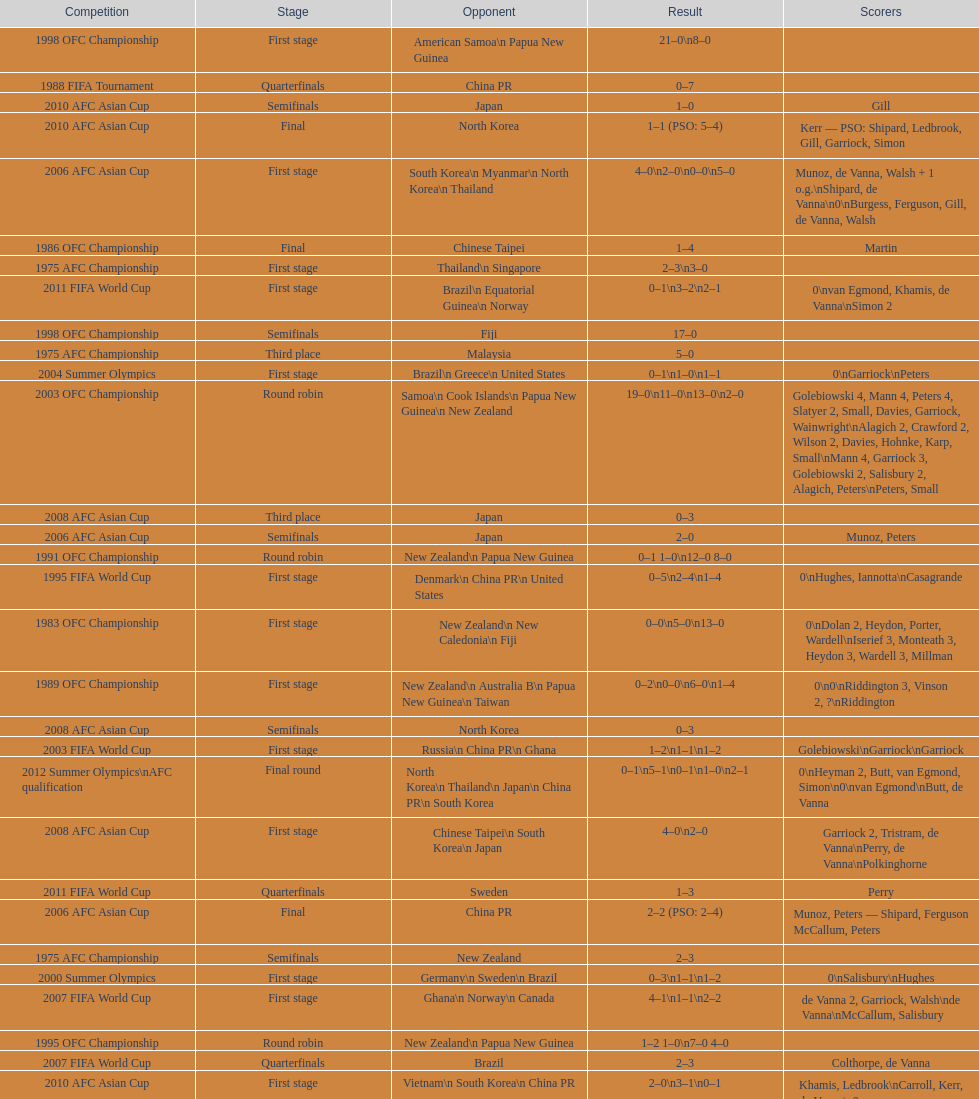How many players scored during the 1983 ofc championship competition? 9. Could you parse the entire table? {'header': ['Competition', 'Stage', 'Opponent', 'Result', 'Scorers'], 'rows': [['1998 OFC Championship', 'First stage', 'American Samoa\\n\xa0Papua New Guinea', '21–0\\n8–0', ''], ['1988 FIFA Tournament', 'Quarterfinals', 'China PR', '0–7', ''], ['2010 AFC Asian Cup', 'Semifinals', 'Japan', '1–0', 'Gill'], ['2010 AFC Asian Cup', 'Final', 'North Korea', '1–1 (PSO: 5–4)', 'Kerr — PSO: Shipard, Ledbrook, Gill, Garriock, Simon'], ['2006 AFC Asian Cup', 'First stage', 'South Korea\\n\xa0Myanmar\\n\xa0North Korea\\n\xa0Thailand', '4–0\\n2–0\\n0–0\\n5–0', 'Munoz, de Vanna, Walsh + 1 o.g.\\nShipard, de Vanna\\n0\\nBurgess, Ferguson, Gill, de Vanna, Walsh'], ['1986 OFC Championship', 'Final', 'Chinese Taipei', '1–4', 'Martin'], ['1975 AFC Championship', 'First stage', 'Thailand\\n\xa0Singapore', '2–3\\n3–0', ''], ['2011 FIFA World Cup', 'First stage', 'Brazil\\n\xa0Equatorial Guinea\\n\xa0Norway', '0–1\\n3–2\\n2–1', '0\\nvan Egmond, Khamis, de Vanna\\nSimon 2'], ['1998 OFC Championship', 'Semifinals', 'Fiji', '17–0', ''], ['1975 AFC Championship', 'Third place', 'Malaysia', '5–0', ''], ['2004 Summer Olympics', 'First stage', 'Brazil\\n\xa0Greece\\n\xa0United States', '0–1\\n1–0\\n1–1', '0\\nGarriock\\nPeters'], ['2003 OFC Championship', 'Round robin', 'Samoa\\n\xa0Cook Islands\\n\xa0Papua New Guinea\\n\xa0New Zealand', '19–0\\n11–0\\n13–0\\n2–0', 'Golebiowski 4, Mann 4, Peters 4, Slatyer 2, Small, Davies, Garriock, Wainwright\\nAlagich 2, Crawford 2, Wilson 2, Davies, Hohnke, Karp, Small\\nMann 4, Garriock 3, Golebiowski 2, Salisbury 2, Alagich, Peters\\nPeters, Small'], ['2008 AFC Asian Cup', 'Third place', 'Japan', '0–3', ''], ['2006 AFC Asian Cup', 'Semifinals', 'Japan', '2–0', 'Munoz, Peters'], ['1991 OFC Championship', 'Round robin', 'New Zealand\\n\xa0Papua New Guinea', '0–1 1–0\\n12–0 8–0', ''], ['1995 FIFA World Cup', 'First stage', 'Denmark\\n\xa0China PR\\n\xa0United States', '0–5\\n2–4\\n1–4', '0\\nHughes, Iannotta\\nCasagrande'], ['1983 OFC Championship', 'First stage', 'New Zealand\\n\xa0New Caledonia\\n\xa0Fiji', '0–0\\n5–0\\n13–0', '0\\nDolan 2, Heydon, Porter, Wardell\\nIserief 3, Monteath 3, Heydon 3, Wardell 3, Millman'], ['1989 OFC Championship', 'First stage', 'New Zealand\\n Australia B\\n\xa0Papua New Guinea\\n\xa0Taiwan', '0–2\\n0–0\\n6–0\\n1–4', '0\\n0\\nRiddington 3, Vinson 2,\xa0?\\nRiddington'], ['2008 AFC Asian Cup', 'Semifinals', 'North Korea', '0–3', ''], ['2003 FIFA World Cup', 'First stage', 'Russia\\n\xa0China PR\\n\xa0Ghana', '1–2\\n1–1\\n1–2', 'Golebiowski\\nGarriock\\nGarriock'], ['2012 Summer Olympics\\nAFC qualification', 'Final round', 'North Korea\\n\xa0Thailand\\n\xa0Japan\\n\xa0China PR\\n\xa0South Korea', '0–1\\n5–1\\n0–1\\n1–0\\n2–1', '0\\nHeyman 2, Butt, van Egmond, Simon\\n0\\nvan Egmond\\nButt, de Vanna'], ['2008 AFC Asian Cup', 'First stage', 'Chinese Taipei\\n\xa0South Korea\\n\xa0Japan', '4–0\\n2–0', 'Garriock 2, Tristram, de Vanna\\nPerry, de Vanna\\nPolkinghorne'], ['2011 FIFA World Cup', 'Quarterfinals', 'Sweden', '1–3', 'Perry'], ['2006 AFC Asian Cup', 'Final', 'China PR', '2–2 (PSO: 2–4)', 'Munoz, Peters — Shipard, Ferguson McCallum, Peters'], ['1975 AFC Championship', 'Semifinals', 'New Zealand', '2–3', ''], ['2000 Summer Olympics', 'First stage', 'Germany\\n\xa0Sweden\\n\xa0Brazil', '0–3\\n1–1\\n1–2', '0\\nSalisbury\\nHughes'], ['2007 FIFA World Cup', 'First stage', 'Ghana\\n\xa0Norway\\n\xa0Canada', '4–1\\n1–1\\n2–2', 'de Vanna 2, Garriock, Walsh\\nde Vanna\\nMcCallum, Salisbury'], ['1995 OFC Championship', 'Round robin', 'New Zealand\\n\xa0Papua New Guinea', '1–2 1–0\\n7–0 4–0', ''], ['2007 FIFA World Cup', 'Quarterfinals', 'Brazil', '2–3', 'Colthorpe, de Vanna'], ['2010 AFC Asian Cup', 'First stage', 'Vietnam\\n\xa0South Korea\\n\xa0China PR', '2–0\\n3–1\\n0–1', 'Khamis, Ledbrook\\nCarroll, Kerr, de Vanna\\n0'], ['2014 AFC Asian Cup', 'First stage', 'Japan\\n\xa0Jordan\\n\xa0Vietnam', 'TBD\\nTBD\\nTBD', ''], ['1986 OFC Championship', 'First stage', 'New Zealand\\n\xa0Chinese Taipei\\n New Zealand B', '1–0\\n0–1\\n2–1', 'Iserief\\n0\\nMateljan, Monteath'], ['1988 FIFA Tournament', 'First stage', 'Brazil\\n\xa0Thailand\\n\xa0Norway', '1–0\\n3–0\\n0–3', ''], ['1998 OFC Championship', 'Final', 'New Zealand', '3–1', ''], ['1983 OFC Championship', 'Final', 'New Zealand', '2–3 (AET)', 'Brentnall, Dolan'], ['1999 FIFA World Cup', 'First stage', 'Ghana\\n\xa0Sweden\\n\xa0China PR', '1–1\\n1–3\\n1–3', 'Murray\\nMurray\\nSalisbury'], ['1989 OFC Championship', 'Third place', 'Australia B', 'not played', ''], ['2004 Summer Olympics', 'Quarterfinals', 'Sweden', '1–2', 'de Vanna']]} 